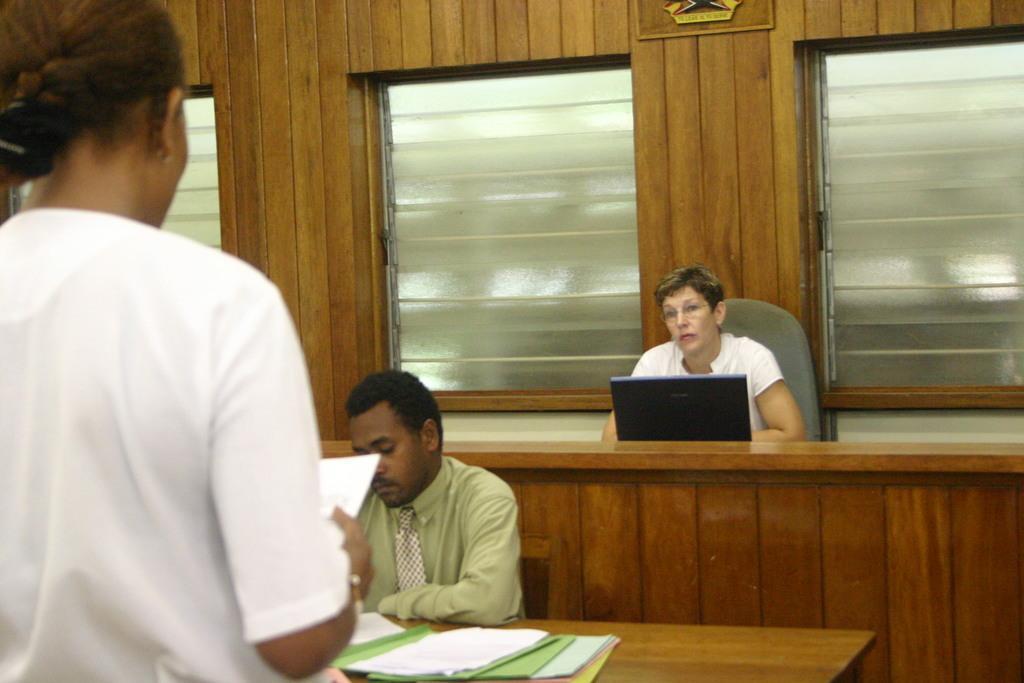Please provide a concise description of this image. In this image I can see a woman Standing and wearing a white shirt is holding few papers in her hand. I can see a person wearing a shirt and tie sitting on a chair in front of a desk, On The desk I can see few files. In the background i can see a woman sitting on the chair with a laptop in front and the wall and few Windows. 